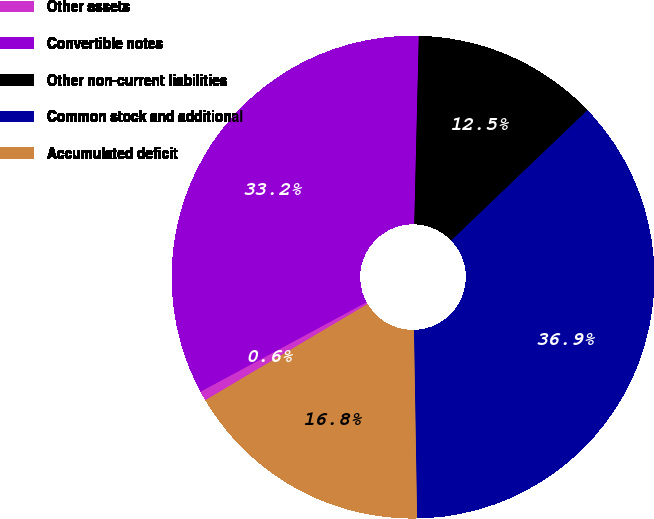Convert chart. <chart><loc_0><loc_0><loc_500><loc_500><pie_chart><fcel>Other assets<fcel>Convertible notes<fcel>Other non-current liabilities<fcel>Common stock and additional<fcel>Accumulated deficit<nl><fcel>0.65%<fcel>33.25%<fcel>12.47%<fcel>36.88%<fcel>16.75%<nl></chart> 